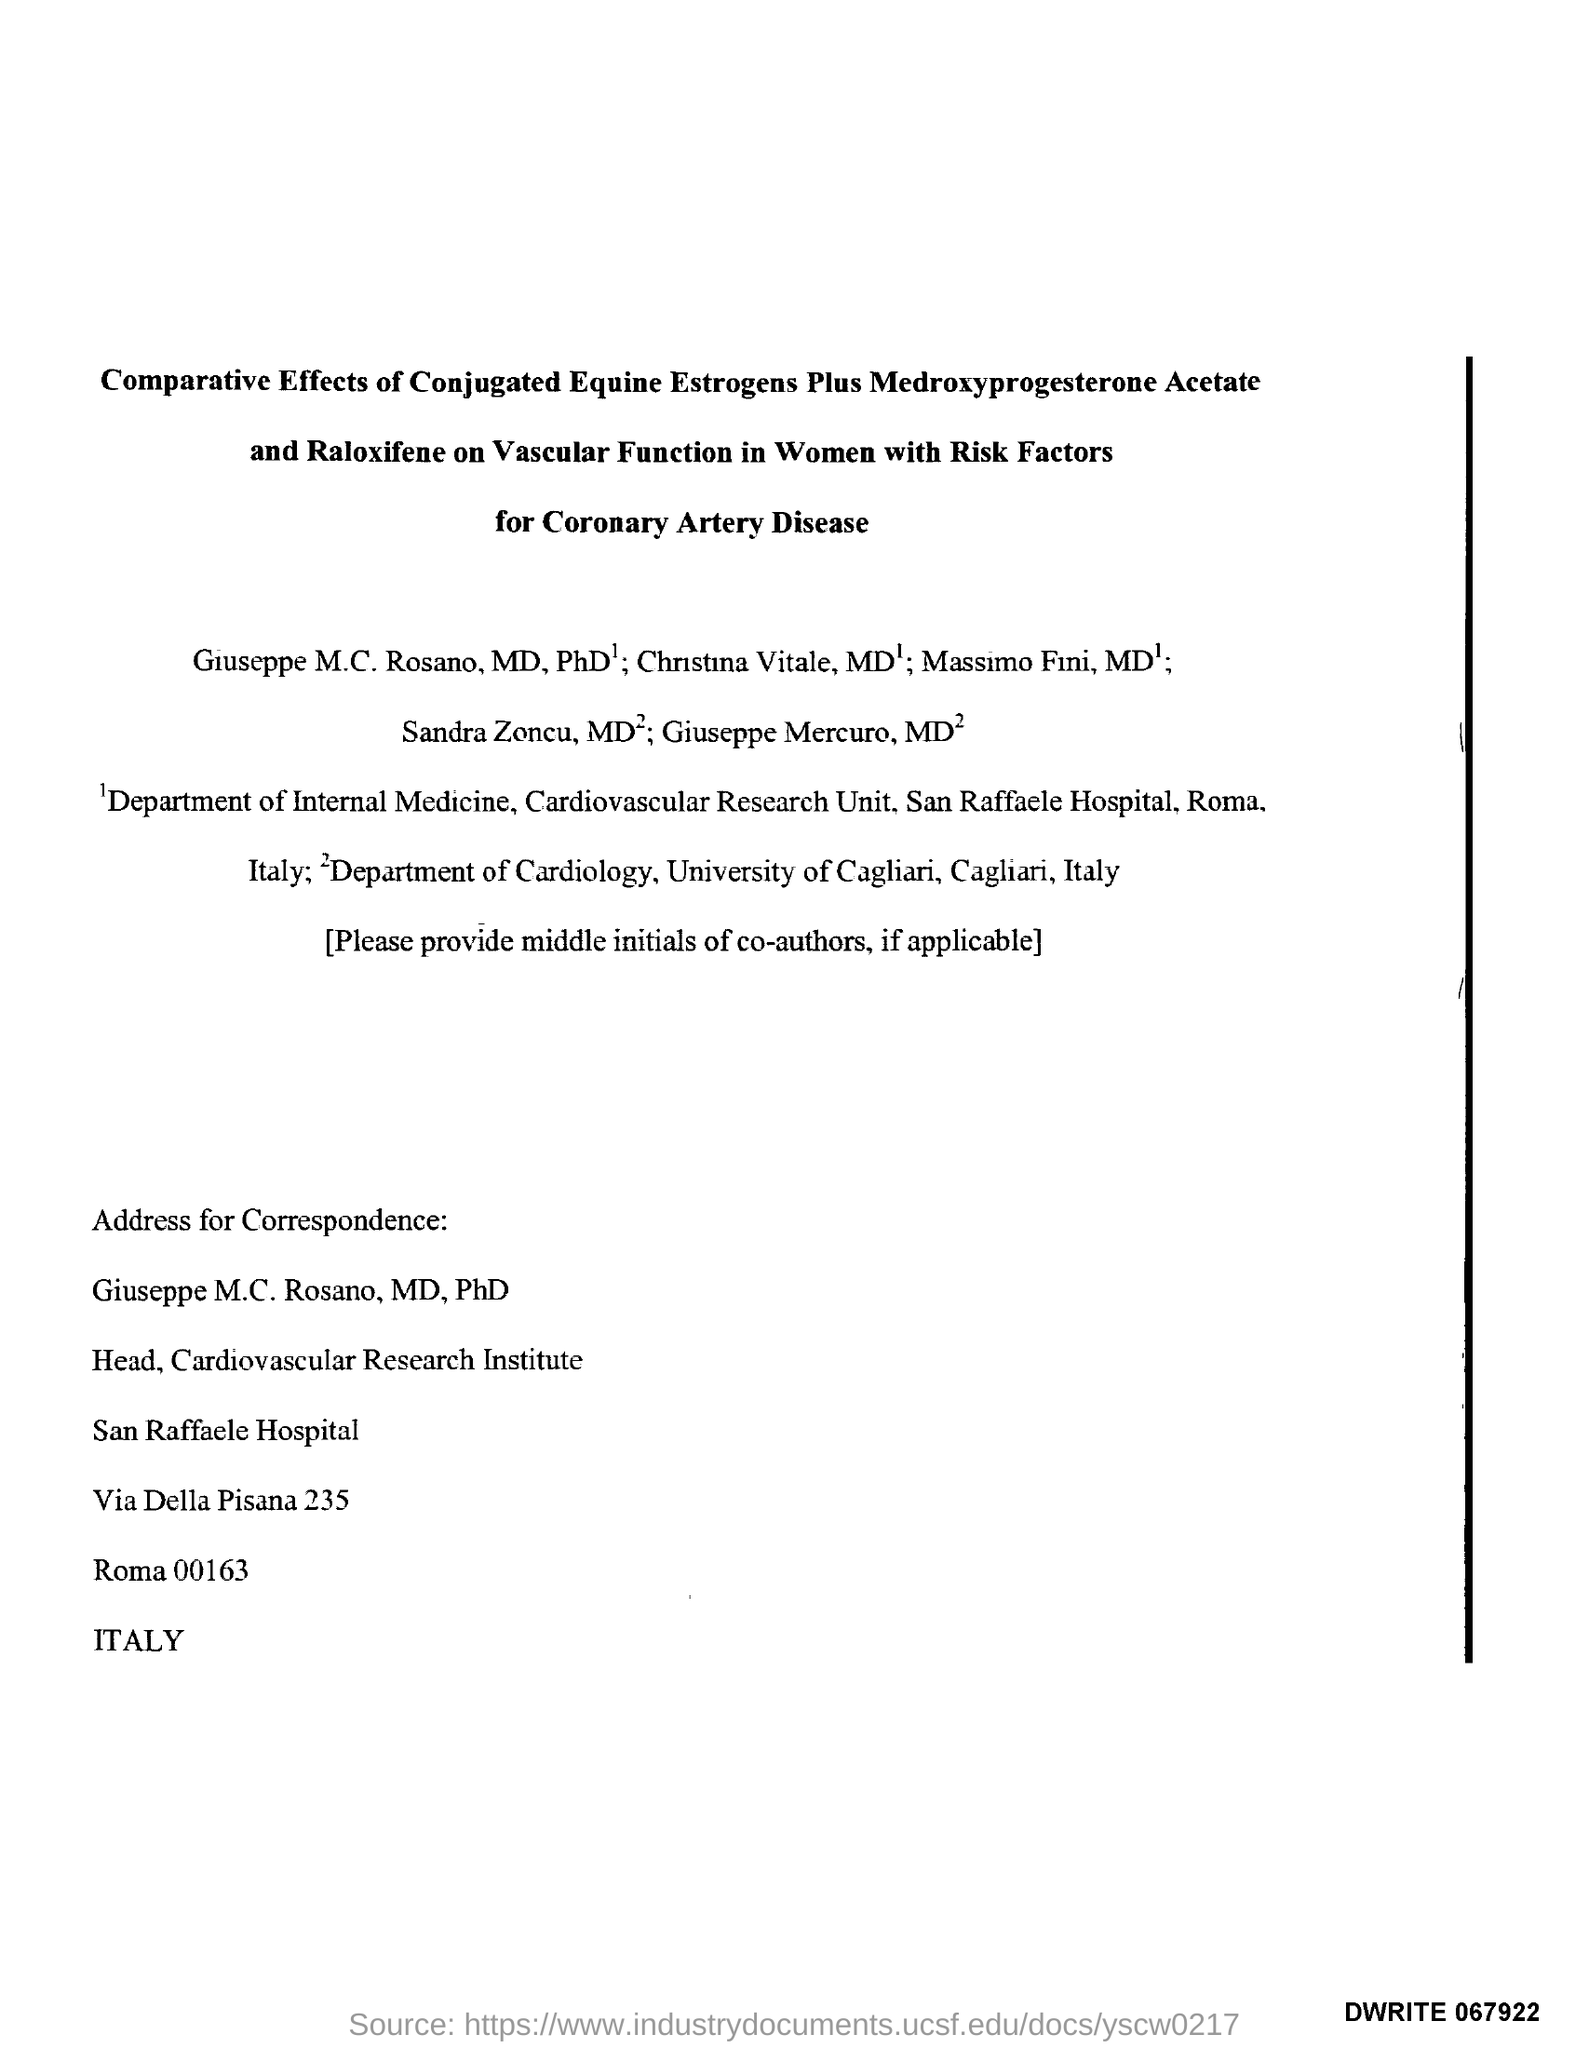Draw attention to some important aspects in this diagram. The individual named Giuseppe M.C. Rosano, who holds the titles of MD and PhD, is designated as the Head of the Cardiovascular Research Institute. 